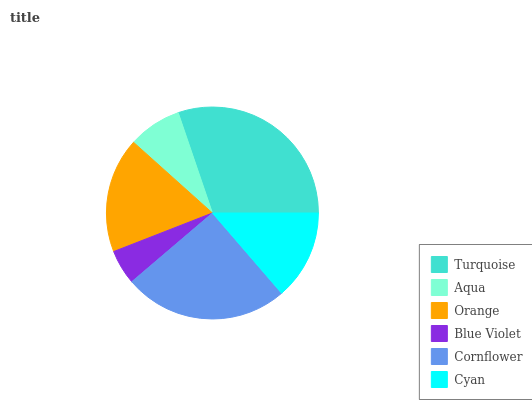Is Blue Violet the minimum?
Answer yes or no. Yes. Is Turquoise the maximum?
Answer yes or no. Yes. Is Aqua the minimum?
Answer yes or no. No. Is Aqua the maximum?
Answer yes or no. No. Is Turquoise greater than Aqua?
Answer yes or no. Yes. Is Aqua less than Turquoise?
Answer yes or no. Yes. Is Aqua greater than Turquoise?
Answer yes or no. No. Is Turquoise less than Aqua?
Answer yes or no. No. Is Orange the high median?
Answer yes or no. Yes. Is Cyan the low median?
Answer yes or no. Yes. Is Blue Violet the high median?
Answer yes or no. No. Is Aqua the low median?
Answer yes or no. No. 